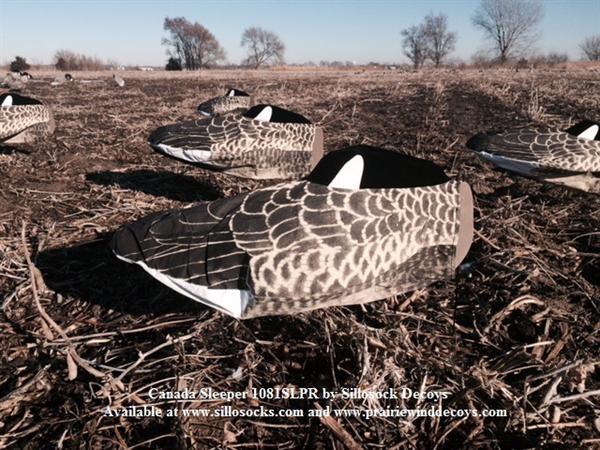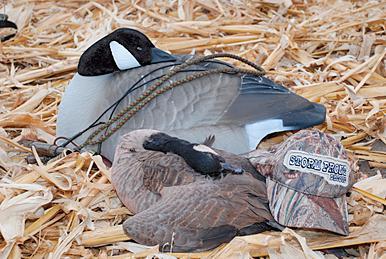The first image is the image on the left, the second image is the image on the right. Examine the images to the left and right. Is the description "The right image features a duck decoy on shredded material, and no image contains more than six decoys in the foreground." accurate? Answer yes or no. Yes. The first image is the image on the left, the second image is the image on the right. Given the left and right images, does the statement "The birds in at least one of the images are near a tree surrounded area." hold true? Answer yes or no. Yes. 